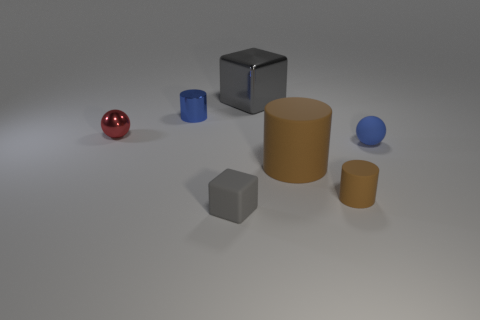Subtract 1 cylinders. How many cylinders are left? 2 Add 3 blue metal cylinders. How many objects exist? 10 Subtract all balls. How many objects are left? 5 Subtract 0 yellow blocks. How many objects are left? 7 Subtract all brown rubber objects. Subtract all large objects. How many objects are left? 3 Add 3 tiny brown things. How many tiny brown things are left? 4 Add 5 large purple matte things. How many large purple matte things exist? 5 